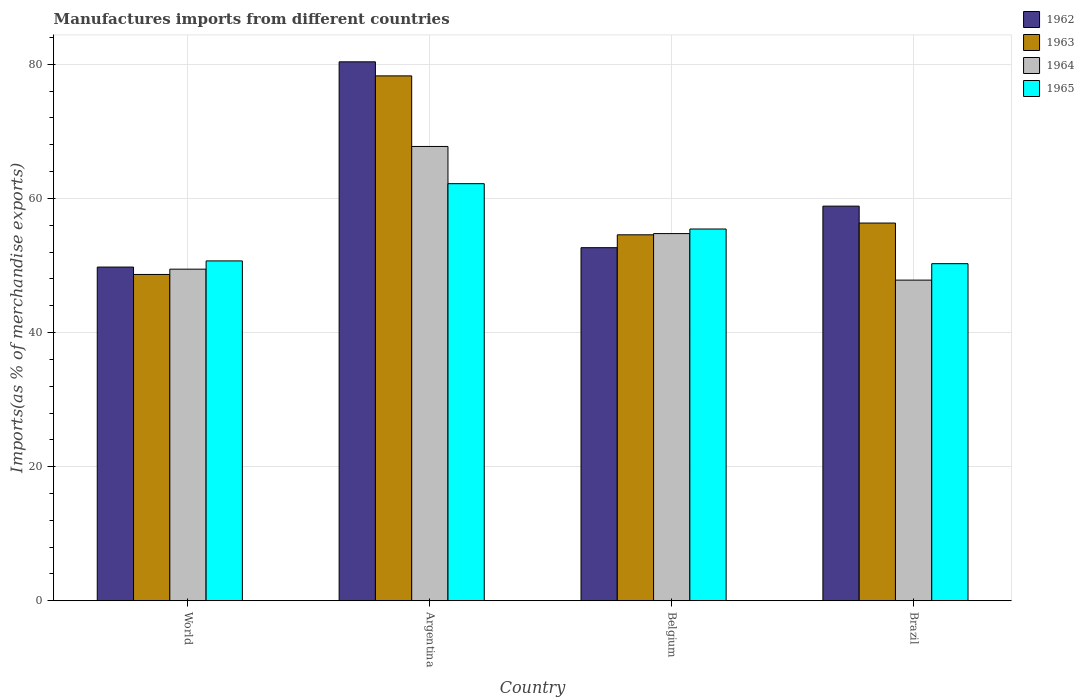How many different coloured bars are there?
Give a very brief answer. 4. Are the number of bars per tick equal to the number of legend labels?
Provide a short and direct response. Yes. What is the label of the 1st group of bars from the left?
Your response must be concise. World. What is the percentage of imports to different countries in 1964 in World?
Ensure brevity in your answer.  49.45. Across all countries, what is the maximum percentage of imports to different countries in 1964?
Make the answer very short. 67.75. Across all countries, what is the minimum percentage of imports to different countries in 1962?
Give a very brief answer. 49.76. In which country was the percentage of imports to different countries in 1962 maximum?
Your answer should be compact. Argentina. In which country was the percentage of imports to different countries in 1962 minimum?
Ensure brevity in your answer.  World. What is the total percentage of imports to different countries in 1962 in the graph?
Give a very brief answer. 241.63. What is the difference between the percentage of imports to different countries in 1962 in Argentina and that in World?
Provide a short and direct response. 30.61. What is the difference between the percentage of imports to different countries in 1965 in World and the percentage of imports to different countries in 1962 in Argentina?
Your answer should be compact. -29.69. What is the average percentage of imports to different countries in 1962 per country?
Provide a short and direct response. 60.41. What is the difference between the percentage of imports to different countries of/in 1962 and percentage of imports to different countries of/in 1964 in Brazil?
Provide a short and direct response. 11.03. What is the ratio of the percentage of imports to different countries in 1965 in Belgium to that in World?
Keep it short and to the point. 1.09. Is the percentage of imports to different countries in 1964 in Argentina less than that in Belgium?
Your response must be concise. No. Is the difference between the percentage of imports to different countries in 1962 in Brazil and World greater than the difference between the percentage of imports to different countries in 1964 in Brazil and World?
Your answer should be very brief. Yes. What is the difference between the highest and the second highest percentage of imports to different countries in 1965?
Offer a very short reply. -11.52. What is the difference between the highest and the lowest percentage of imports to different countries in 1963?
Make the answer very short. 29.61. Is it the case that in every country, the sum of the percentage of imports to different countries in 1963 and percentage of imports to different countries in 1962 is greater than the sum of percentage of imports to different countries in 1965 and percentage of imports to different countries in 1964?
Provide a succinct answer. Yes. What does the 4th bar from the left in World represents?
Your answer should be very brief. 1965. What does the 2nd bar from the right in Brazil represents?
Your answer should be very brief. 1964. Is it the case that in every country, the sum of the percentage of imports to different countries in 1965 and percentage of imports to different countries in 1964 is greater than the percentage of imports to different countries in 1963?
Ensure brevity in your answer.  Yes. How many bars are there?
Keep it short and to the point. 16. How many countries are there in the graph?
Provide a short and direct response. 4. Are the values on the major ticks of Y-axis written in scientific E-notation?
Your response must be concise. No. Where does the legend appear in the graph?
Offer a very short reply. Top right. What is the title of the graph?
Make the answer very short. Manufactures imports from different countries. What is the label or title of the X-axis?
Make the answer very short. Country. What is the label or title of the Y-axis?
Your answer should be very brief. Imports(as % of merchandise exports). What is the Imports(as % of merchandise exports) of 1962 in World?
Keep it short and to the point. 49.76. What is the Imports(as % of merchandise exports) of 1963 in World?
Provide a short and direct response. 48.66. What is the Imports(as % of merchandise exports) of 1964 in World?
Make the answer very short. 49.45. What is the Imports(as % of merchandise exports) of 1965 in World?
Make the answer very short. 50.68. What is the Imports(as % of merchandise exports) of 1962 in Argentina?
Ensure brevity in your answer.  80.37. What is the Imports(as % of merchandise exports) in 1963 in Argentina?
Keep it short and to the point. 78.27. What is the Imports(as % of merchandise exports) in 1964 in Argentina?
Ensure brevity in your answer.  67.75. What is the Imports(as % of merchandise exports) of 1965 in Argentina?
Your answer should be very brief. 62.19. What is the Imports(as % of merchandise exports) of 1962 in Belgium?
Your answer should be very brief. 52.65. What is the Imports(as % of merchandise exports) in 1963 in Belgium?
Give a very brief answer. 54.57. What is the Imports(as % of merchandise exports) in 1964 in Belgium?
Your answer should be very brief. 54.75. What is the Imports(as % of merchandise exports) in 1965 in Belgium?
Give a very brief answer. 55.44. What is the Imports(as % of merchandise exports) of 1962 in Brazil?
Provide a succinct answer. 58.85. What is the Imports(as % of merchandise exports) in 1963 in Brazil?
Offer a very short reply. 56.32. What is the Imports(as % of merchandise exports) of 1964 in Brazil?
Ensure brevity in your answer.  47.82. What is the Imports(as % of merchandise exports) of 1965 in Brazil?
Your response must be concise. 50.27. Across all countries, what is the maximum Imports(as % of merchandise exports) in 1962?
Your response must be concise. 80.37. Across all countries, what is the maximum Imports(as % of merchandise exports) of 1963?
Give a very brief answer. 78.27. Across all countries, what is the maximum Imports(as % of merchandise exports) in 1964?
Make the answer very short. 67.75. Across all countries, what is the maximum Imports(as % of merchandise exports) in 1965?
Provide a succinct answer. 62.19. Across all countries, what is the minimum Imports(as % of merchandise exports) in 1962?
Offer a very short reply. 49.76. Across all countries, what is the minimum Imports(as % of merchandise exports) in 1963?
Offer a very short reply. 48.66. Across all countries, what is the minimum Imports(as % of merchandise exports) in 1964?
Give a very brief answer. 47.82. Across all countries, what is the minimum Imports(as % of merchandise exports) in 1965?
Your answer should be very brief. 50.27. What is the total Imports(as % of merchandise exports) in 1962 in the graph?
Keep it short and to the point. 241.63. What is the total Imports(as % of merchandise exports) in 1963 in the graph?
Keep it short and to the point. 237.83. What is the total Imports(as % of merchandise exports) in 1964 in the graph?
Offer a very short reply. 219.76. What is the total Imports(as % of merchandise exports) of 1965 in the graph?
Provide a succinct answer. 218.58. What is the difference between the Imports(as % of merchandise exports) of 1962 in World and that in Argentina?
Provide a succinct answer. -30.61. What is the difference between the Imports(as % of merchandise exports) in 1963 in World and that in Argentina?
Offer a very short reply. -29.61. What is the difference between the Imports(as % of merchandise exports) of 1964 in World and that in Argentina?
Ensure brevity in your answer.  -18.3. What is the difference between the Imports(as % of merchandise exports) in 1965 in World and that in Argentina?
Provide a short and direct response. -11.52. What is the difference between the Imports(as % of merchandise exports) in 1962 in World and that in Belgium?
Keep it short and to the point. -2.89. What is the difference between the Imports(as % of merchandise exports) of 1963 in World and that in Belgium?
Your answer should be very brief. -5.91. What is the difference between the Imports(as % of merchandise exports) in 1964 in World and that in Belgium?
Provide a short and direct response. -5.31. What is the difference between the Imports(as % of merchandise exports) in 1965 in World and that in Belgium?
Make the answer very short. -4.76. What is the difference between the Imports(as % of merchandise exports) of 1962 in World and that in Brazil?
Your answer should be compact. -9.09. What is the difference between the Imports(as % of merchandise exports) of 1963 in World and that in Brazil?
Provide a short and direct response. -7.66. What is the difference between the Imports(as % of merchandise exports) of 1964 in World and that in Brazil?
Your answer should be compact. 1.63. What is the difference between the Imports(as % of merchandise exports) in 1965 in World and that in Brazil?
Offer a terse response. 0.41. What is the difference between the Imports(as % of merchandise exports) in 1962 in Argentina and that in Belgium?
Your response must be concise. 27.71. What is the difference between the Imports(as % of merchandise exports) in 1963 in Argentina and that in Belgium?
Your answer should be compact. 23.7. What is the difference between the Imports(as % of merchandise exports) of 1964 in Argentina and that in Belgium?
Ensure brevity in your answer.  12.99. What is the difference between the Imports(as % of merchandise exports) in 1965 in Argentina and that in Belgium?
Make the answer very short. 6.76. What is the difference between the Imports(as % of merchandise exports) of 1962 in Argentina and that in Brazil?
Provide a short and direct response. 21.52. What is the difference between the Imports(as % of merchandise exports) in 1963 in Argentina and that in Brazil?
Give a very brief answer. 21.95. What is the difference between the Imports(as % of merchandise exports) of 1964 in Argentina and that in Brazil?
Offer a terse response. 19.93. What is the difference between the Imports(as % of merchandise exports) in 1965 in Argentina and that in Brazil?
Ensure brevity in your answer.  11.93. What is the difference between the Imports(as % of merchandise exports) in 1962 in Belgium and that in Brazil?
Ensure brevity in your answer.  -6.19. What is the difference between the Imports(as % of merchandise exports) of 1963 in Belgium and that in Brazil?
Provide a short and direct response. -1.75. What is the difference between the Imports(as % of merchandise exports) of 1964 in Belgium and that in Brazil?
Offer a terse response. 6.94. What is the difference between the Imports(as % of merchandise exports) of 1965 in Belgium and that in Brazil?
Offer a very short reply. 5.17. What is the difference between the Imports(as % of merchandise exports) of 1962 in World and the Imports(as % of merchandise exports) of 1963 in Argentina?
Your answer should be very brief. -28.51. What is the difference between the Imports(as % of merchandise exports) in 1962 in World and the Imports(as % of merchandise exports) in 1964 in Argentina?
Offer a very short reply. -17.98. What is the difference between the Imports(as % of merchandise exports) in 1962 in World and the Imports(as % of merchandise exports) in 1965 in Argentina?
Your answer should be very brief. -12.43. What is the difference between the Imports(as % of merchandise exports) in 1963 in World and the Imports(as % of merchandise exports) in 1964 in Argentina?
Your answer should be very brief. -19.09. What is the difference between the Imports(as % of merchandise exports) of 1963 in World and the Imports(as % of merchandise exports) of 1965 in Argentina?
Keep it short and to the point. -13.54. What is the difference between the Imports(as % of merchandise exports) in 1964 in World and the Imports(as % of merchandise exports) in 1965 in Argentina?
Provide a succinct answer. -12.75. What is the difference between the Imports(as % of merchandise exports) of 1962 in World and the Imports(as % of merchandise exports) of 1963 in Belgium?
Your response must be concise. -4.81. What is the difference between the Imports(as % of merchandise exports) of 1962 in World and the Imports(as % of merchandise exports) of 1964 in Belgium?
Offer a terse response. -4.99. What is the difference between the Imports(as % of merchandise exports) in 1962 in World and the Imports(as % of merchandise exports) in 1965 in Belgium?
Your answer should be compact. -5.67. What is the difference between the Imports(as % of merchandise exports) of 1963 in World and the Imports(as % of merchandise exports) of 1964 in Belgium?
Provide a short and direct response. -6.09. What is the difference between the Imports(as % of merchandise exports) of 1963 in World and the Imports(as % of merchandise exports) of 1965 in Belgium?
Ensure brevity in your answer.  -6.78. What is the difference between the Imports(as % of merchandise exports) of 1964 in World and the Imports(as % of merchandise exports) of 1965 in Belgium?
Give a very brief answer. -5.99. What is the difference between the Imports(as % of merchandise exports) of 1962 in World and the Imports(as % of merchandise exports) of 1963 in Brazil?
Provide a succinct answer. -6.56. What is the difference between the Imports(as % of merchandise exports) in 1962 in World and the Imports(as % of merchandise exports) in 1964 in Brazil?
Provide a succinct answer. 1.95. What is the difference between the Imports(as % of merchandise exports) of 1962 in World and the Imports(as % of merchandise exports) of 1965 in Brazil?
Keep it short and to the point. -0.51. What is the difference between the Imports(as % of merchandise exports) in 1963 in World and the Imports(as % of merchandise exports) in 1964 in Brazil?
Your response must be concise. 0.84. What is the difference between the Imports(as % of merchandise exports) in 1963 in World and the Imports(as % of merchandise exports) in 1965 in Brazil?
Keep it short and to the point. -1.61. What is the difference between the Imports(as % of merchandise exports) in 1964 in World and the Imports(as % of merchandise exports) in 1965 in Brazil?
Ensure brevity in your answer.  -0.82. What is the difference between the Imports(as % of merchandise exports) in 1962 in Argentina and the Imports(as % of merchandise exports) in 1963 in Belgium?
Ensure brevity in your answer.  25.79. What is the difference between the Imports(as % of merchandise exports) of 1962 in Argentina and the Imports(as % of merchandise exports) of 1964 in Belgium?
Your answer should be very brief. 25.61. What is the difference between the Imports(as % of merchandise exports) of 1962 in Argentina and the Imports(as % of merchandise exports) of 1965 in Belgium?
Keep it short and to the point. 24.93. What is the difference between the Imports(as % of merchandise exports) in 1963 in Argentina and the Imports(as % of merchandise exports) in 1964 in Belgium?
Provide a succinct answer. 23.52. What is the difference between the Imports(as % of merchandise exports) in 1963 in Argentina and the Imports(as % of merchandise exports) in 1965 in Belgium?
Offer a very short reply. 22.83. What is the difference between the Imports(as % of merchandise exports) of 1964 in Argentina and the Imports(as % of merchandise exports) of 1965 in Belgium?
Offer a very short reply. 12.31. What is the difference between the Imports(as % of merchandise exports) in 1962 in Argentina and the Imports(as % of merchandise exports) in 1963 in Brazil?
Provide a short and direct response. 24.04. What is the difference between the Imports(as % of merchandise exports) of 1962 in Argentina and the Imports(as % of merchandise exports) of 1964 in Brazil?
Provide a succinct answer. 32.55. What is the difference between the Imports(as % of merchandise exports) in 1962 in Argentina and the Imports(as % of merchandise exports) in 1965 in Brazil?
Offer a very short reply. 30.1. What is the difference between the Imports(as % of merchandise exports) of 1963 in Argentina and the Imports(as % of merchandise exports) of 1964 in Brazil?
Your response must be concise. 30.45. What is the difference between the Imports(as % of merchandise exports) of 1963 in Argentina and the Imports(as % of merchandise exports) of 1965 in Brazil?
Offer a terse response. 28. What is the difference between the Imports(as % of merchandise exports) of 1964 in Argentina and the Imports(as % of merchandise exports) of 1965 in Brazil?
Your answer should be very brief. 17.48. What is the difference between the Imports(as % of merchandise exports) of 1962 in Belgium and the Imports(as % of merchandise exports) of 1963 in Brazil?
Keep it short and to the point. -3.67. What is the difference between the Imports(as % of merchandise exports) of 1962 in Belgium and the Imports(as % of merchandise exports) of 1964 in Brazil?
Your answer should be compact. 4.84. What is the difference between the Imports(as % of merchandise exports) of 1962 in Belgium and the Imports(as % of merchandise exports) of 1965 in Brazil?
Ensure brevity in your answer.  2.39. What is the difference between the Imports(as % of merchandise exports) in 1963 in Belgium and the Imports(as % of merchandise exports) in 1964 in Brazil?
Provide a succinct answer. 6.76. What is the difference between the Imports(as % of merchandise exports) of 1963 in Belgium and the Imports(as % of merchandise exports) of 1965 in Brazil?
Offer a terse response. 4.31. What is the difference between the Imports(as % of merchandise exports) of 1964 in Belgium and the Imports(as % of merchandise exports) of 1965 in Brazil?
Offer a very short reply. 4.49. What is the average Imports(as % of merchandise exports) of 1962 per country?
Offer a terse response. 60.41. What is the average Imports(as % of merchandise exports) of 1963 per country?
Make the answer very short. 59.46. What is the average Imports(as % of merchandise exports) of 1964 per country?
Your answer should be very brief. 54.94. What is the average Imports(as % of merchandise exports) in 1965 per country?
Provide a succinct answer. 54.64. What is the difference between the Imports(as % of merchandise exports) of 1962 and Imports(as % of merchandise exports) of 1963 in World?
Ensure brevity in your answer.  1.1. What is the difference between the Imports(as % of merchandise exports) of 1962 and Imports(as % of merchandise exports) of 1964 in World?
Make the answer very short. 0.31. What is the difference between the Imports(as % of merchandise exports) of 1962 and Imports(as % of merchandise exports) of 1965 in World?
Give a very brief answer. -0.92. What is the difference between the Imports(as % of merchandise exports) of 1963 and Imports(as % of merchandise exports) of 1964 in World?
Your response must be concise. -0.79. What is the difference between the Imports(as % of merchandise exports) in 1963 and Imports(as % of merchandise exports) in 1965 in World?
Provide a succinct answer. -2.02. What is the difference between the Imports(as % of merchandise exports) of 1964 and Imports(as % of merchandise exports) of 1965 in World?
Make the answer very short. -1.23. What is the difference between the Imports(as % of merchandise exports) in 1962 and Imports(as % of merchandise exports) in 1963 in Argentina?
Provide a short and direct response. 2.1. What is the difference between the Imports(as % of merchandise exports) of 1962 and Imports(as % of merchandise exports) of 1964 in Argentina?
Offer a terse response. 12.62. What is the difference between the Imports(as % of merchandise exports) in 1962 and Imports(as % of merchandise exports) in 1965 in Argentina?
Your answer should be compact. 18.17. What is the difference between the Imports(as % of merchandise exports) of 1963 and Imports(as % of merchandise exports) of 1964 in Argentina?
Your answer should be compact. 10.52. What is the difference between the Imports(as % of merchandise exports) of 1963 and Imports(as % of merchandise exports) of 1965 in Argentina?
Offer a very short reply. 16.08. What is the difference between the Imports(as % of merchandise exports) in 1964 and Imports(as % of merchandise exports) in 1965 in Argentina?
Your answer should be compact. 5.55. What is the difference between the Imports(as % of merchandise exports) of 1962 and Imports(as % of merchandise exports) of 1963 in Belgium?
Keep it short and to the point. -1.92. What is the difference between the Imports(as % of merchandise exports) in 1962 and Imports(as % of merchandise exports) in 1964 in Belgium?
Offer a very short reply. -2.1. What is the difference between the Imports(as % of merchandise exports) of 1962 and Imports(as % of merchandise exports) of 1965 in Belgium?
Provide a succinct answer. -2.78. What is the difference between the Imports(as % of merchandise exports) of 1963 and Imports(as % of merchandise exports) of 1964 in Belgium?
Your answer should be compact. -0.18. What is the difference between the Imports(as % of merchandise exports) of 1963 and Imports(as % of merchandise exports) of 1965 in Belgium?
Provide a succinct answer. -0.86. What is the difference between the Imports(as % of merchandise exports) of 1964 and Imports(as % of merchandise exports) of 1965 in Belgium?
Offer a terse response. -0.68. What is the difference between the Imports(as % of merchandise exports) in 1962 and Imports(as % of merchandise exports) in 1963 in Brazil?
Make the answer very short. 2.52. What is the difference between the Imports(as % of merchandise exports) of 1962 and Imports(as % of merchandise exports) of 1964 in Brazil?
Your answer should be very brief. 11.03. What is the difference between the Imports(as % of merchandise exports) in 1962 and Imports(as % of merchandise exports) in 1965 in Brazil?
Your answer should be compact. 8.58. What is the difference between the Imports(as % of merchandise exports) of 1963 and Imports(as % of merchandise exports) of 1964 in Brazil?
Provide a succinct answer. 8.51. What is the difference between the Imports(as % of merchandise exports) in 1963 and Imports(as % of merchandise exports) in 1965 in Brazil?
Ensure brevity in your answer.  6.06. What is the difference between the Imports(as % of merchandise exports) in 1964 and Imports(as % of merchandise exports) in 1965 in Brazil?
Provide a short and direct response. -2.45. What is the ratio of the Imports(as % of merchandise exports) in 1962 in World to that in Argentina?
Your answer should be compact. 0.62. What is the ratio of the Imports(as % of merchandise exports) of 1963 in World to that in Argentina?
Provide a succinct answer. 0.62. What is the ratio of the Imports(as % of merchandise exports) in 1964 in World to that in Argentina?
Your answer should be very brief. 0.73. What is the ratio of the Imports(as % of merchandise exports) of 1965 in World to that in Argentina?
Offer a very short reply. 0.81. What is the ratio of the Imports(as % of merchandise exports) of 1962 in World to that in Belgium?
Keep it short and to the point. 0.95. What is the ratio of the Imports(as % of merchandise exports) in 1963 in World to that in Belgium?
Ensure brevity in your answer.  0.89. What is the ratio of the Imports(as % of merchandise exports) in 1964 in World to that in Belgium?
Give a very brief answer. 0.9. What is the ratio of the Imports(as % of merchandise exports) in 1965 in World to that in Belgium?
Keep it short and to the point. 0.91. What is the ratio of the Imports(as % of merchandise exports) in 1962 in World to that in Brazil?
Your response must be concise. 0.85. What is the ratio of the Imports(as % of merchandise exports) in 1963 in World to that in Brazil?
Make the answer very short. 0.86. What is the ratio of the Imports(as % of merchandise exports) in 1964 in World to that in Brazil?
Your answer should be very brief. 1.03. What is the ratio of the Imports(as % of merchandise exports) in 1965 in World to that in Brazil?
Provide a succinct answer. 1.01. What is the ratio of the Imports(as % of merchandise exports) in 1962 in Argentina to that in Belgium?
Provide a succinct answer. 1.53. What is the ratio of the Imports(as % of merchandise exports) of 1963 in Argentina to that in Belgium?
Your answer should be very brief. 1.43. What is the ratio of the Imports(as % of merchandise exports) of 1964 in Argentina to that in Belgium?
Keep it short and to the point. 1.24. What is the ratio of the Imports(as % of merchandise exports) in 1965 in Argentina to that in Belgium?
Give a very brief answer. 1.12. What is the ratio of the Imports(as % of merchandise exports) of 1962 in Argentina to that in Brazil?
Give a very brief answer. 1.37. What is the ratio of the Imports(as % of merchandise exports) of 1963 in Argentina to that in Brazil?
Make the answer very short. 1.39. What is the ratio of the Imports(as % of merchandise exports) in 1964 in Argentina to that in Brazil?
Keep it short and to the point. 1.42. What is the ratio of the Imports(as % of merchandise exports) in 1965 in Argentina to that in Brazil?
Make the answer very short. 1.24. What is the ratio of the Imports(as % of merchandise exports) of 1962 in Belgium to that in Brazil?
Make the answer very short. 0.89. What is the ratio of the Imports(as % of merchandise exports) of 1963 in Belgium to that in Brazil?
Your answer should be compact. 0.97. What is the ratio of the Imports(as % of merchandise exports) in 1964 in Belgium to that in Brazil?
Make the answer very short. 1.15. What is the ratio of the Imports(as % of merchandise exports) of 1965 in Belgium to that in Brazil?
Your response must be concise. 1.1. What is the difference between the highest and the second highest Imports(as % of merchandise exports) of 1962?
Give a very brief answer. 21.52. What is the difference between the highest and the second highest Imports(as % of merchandise exports) in 1963?
Provide a short and direct response. 21.95. What is the difference between the highest and the second highest Imports(as % of merchandise exports) in 1964?
Your answer should be compact. 12.99. What is the difference between the highest and the second highest Imports(as % of merchandise exports) in 1965?
Your answer should be compact. 6.76. What is the difference between the highest and the lowest Imports(as % of merchandise exports) of 1962?
Ensure brevity in your answer.  30.61. What is the difference between the highest and the lowest Imports(as % of merchandise exports) of 1963?
Make the answer very short. 29.61. What is the difference between the highest and the lowest Imports(as % of merchandise exports) in 1964?
Offer a very short reply. 19.93. What is the difference between the highest and the lowest Imports(as % of merchandise exports) of 1965?
Your answer should be compact. 11.93. 